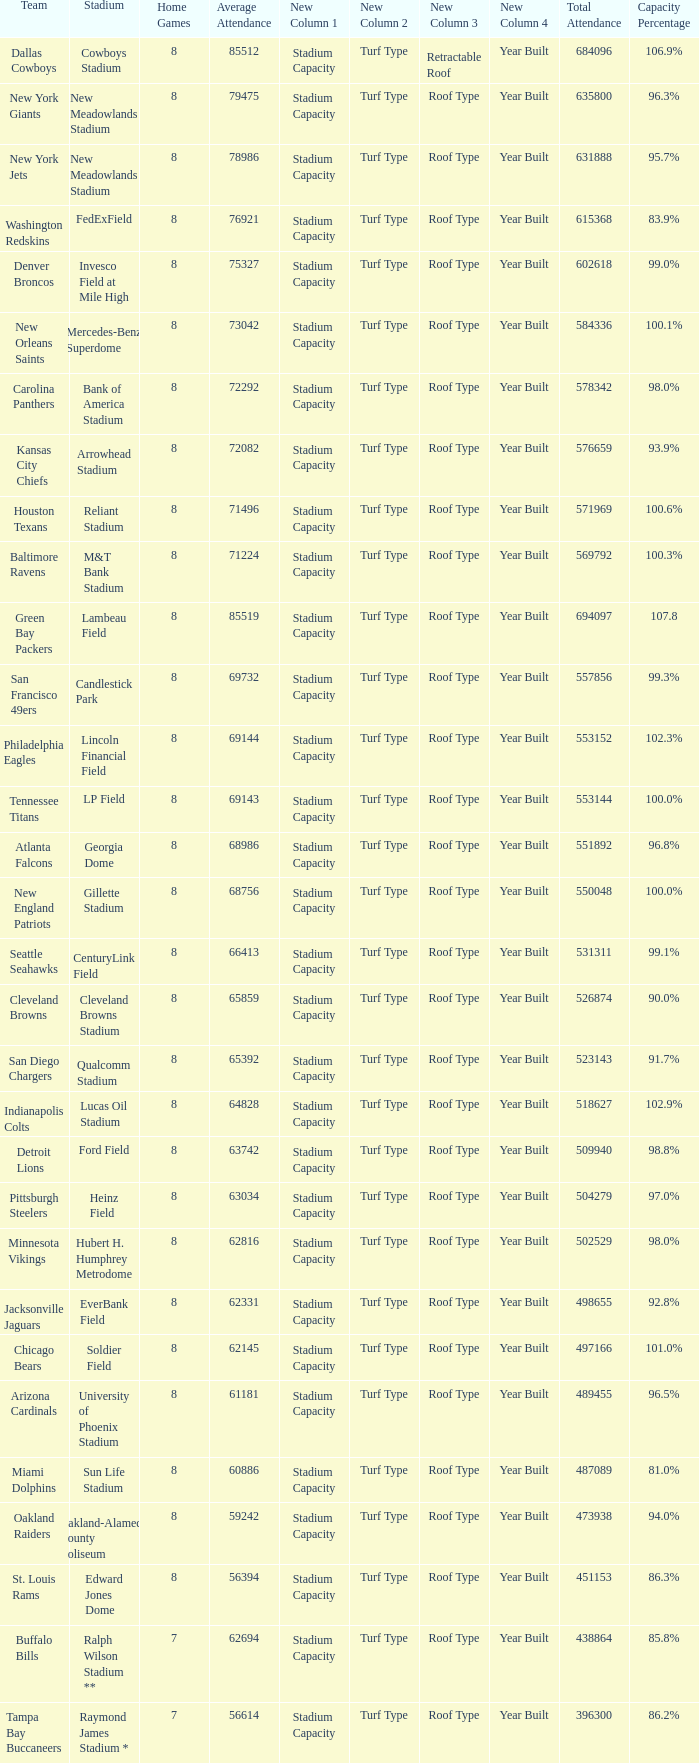What is the name of the team when the stadium is listed as Edward Jones Dome? St. Louis Rams. 